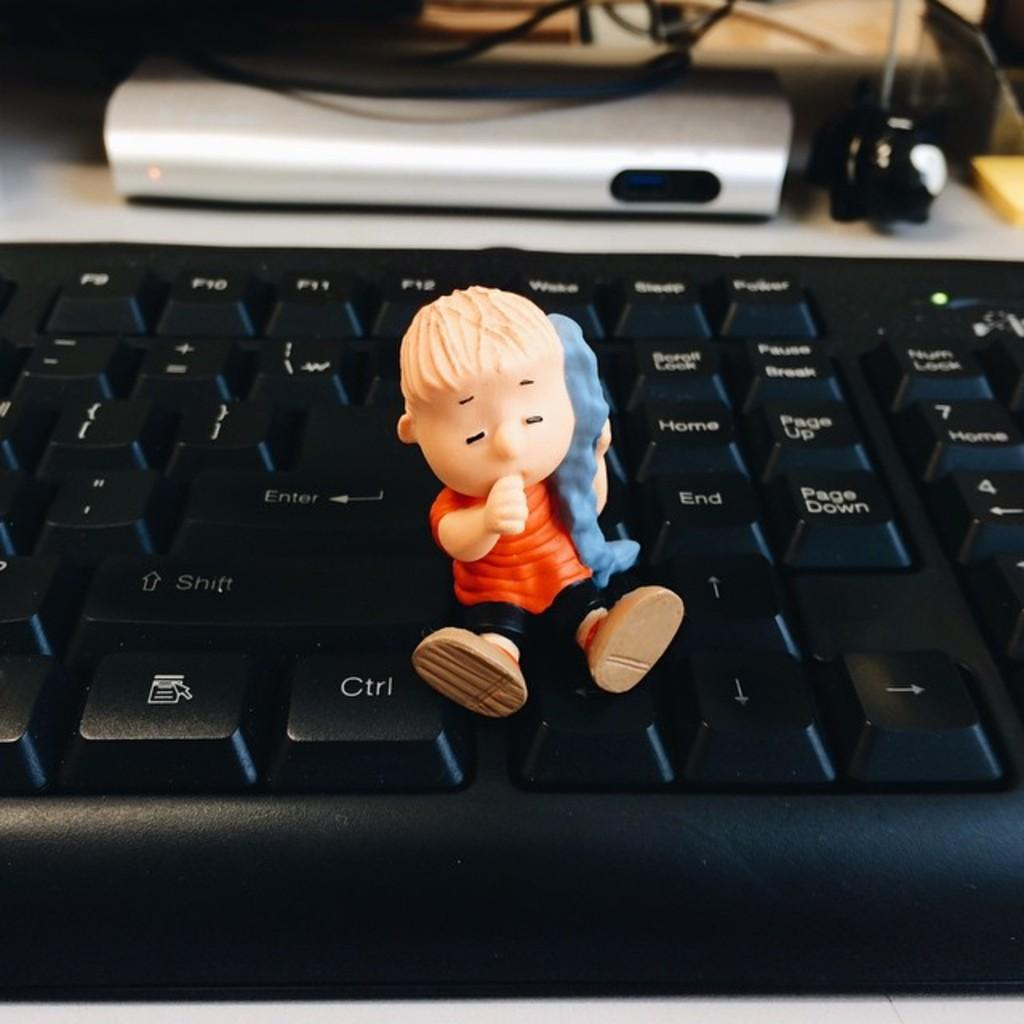<image>
Summarize the visual content of the image. On a keyboard, a Linus toy sits next to the keys labeled Shift and Ctrl 